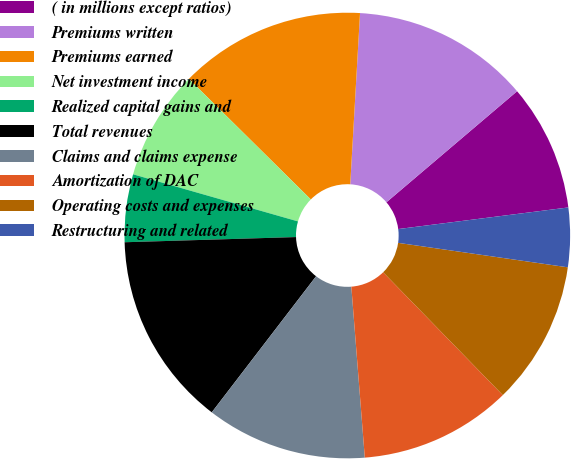Convert chart. <chart><loc_0><loc_0><loc_500><loc_500><pie_chart><fcel>( in millions except ratios)<fcel>Premiums written<fcel>Premiums earned<fcel>Net investment income<fcel>Realized capital gains and<fcel>Total revenues<fcel>Claims and claims expense<fcel>Amortization of DAC<fcel>Operating costs and expenses<fcel>Restructuring and related<nl><fcel>9.2%<fcel>12.88%<fcel>13.5%<fcel>7.98%<fcel>4.91%<fcel>14.11%<fcel>11.66%<fcel>11.04%<fcel>10.43%<fcel>4.29%<nl></chart> 